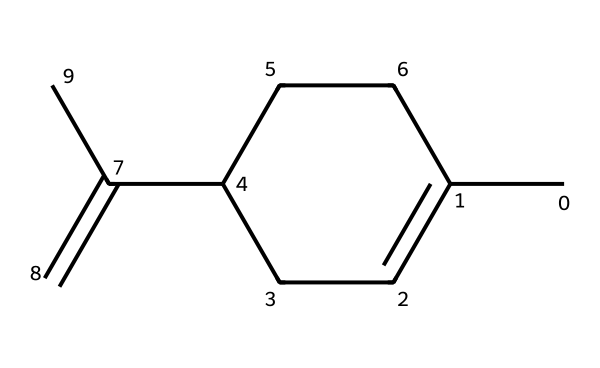What is the molecular formula of limonene? To determine the molecular formula, we count the number of each type of atom in the structure. The structure contains 10 carbon atoms (C) and 16 hydrogen atoms (H). Therefore, the molecular formula is C10H16.
Answer: C10H16 How many rings are present in limonene? The provided SMILES structure indicates a cyclic component due to the presence of the ‘C1’ which indicates the start of a ring. As there is only one portion labeled with ‘C1’, there is one ring in the structure.
Answer: 1 What geometric isomerism is exhibited by limonene? Limonene exhibits cis-trans isomerism due to the presence of two substituents (the two "C" groups adjacent to the double bond “C=C”) that can be arranged differently in space around the double bond.
Answer: cis-trans How many double bonds are in limonene? Inspecting the SMILES structure, we identify one double bond in the form of “C=C” at the end of the carbon chain. Thus, there is one double bond present.
Answer: 1 What is the significance of geometric isomerism in limonene? Geometric isomerism affects the properties and aroma of limonene. The two isomers (cis and trans) can have different scents, which impacts their effectiveness in air fresheners.
Answer: aroma difference 